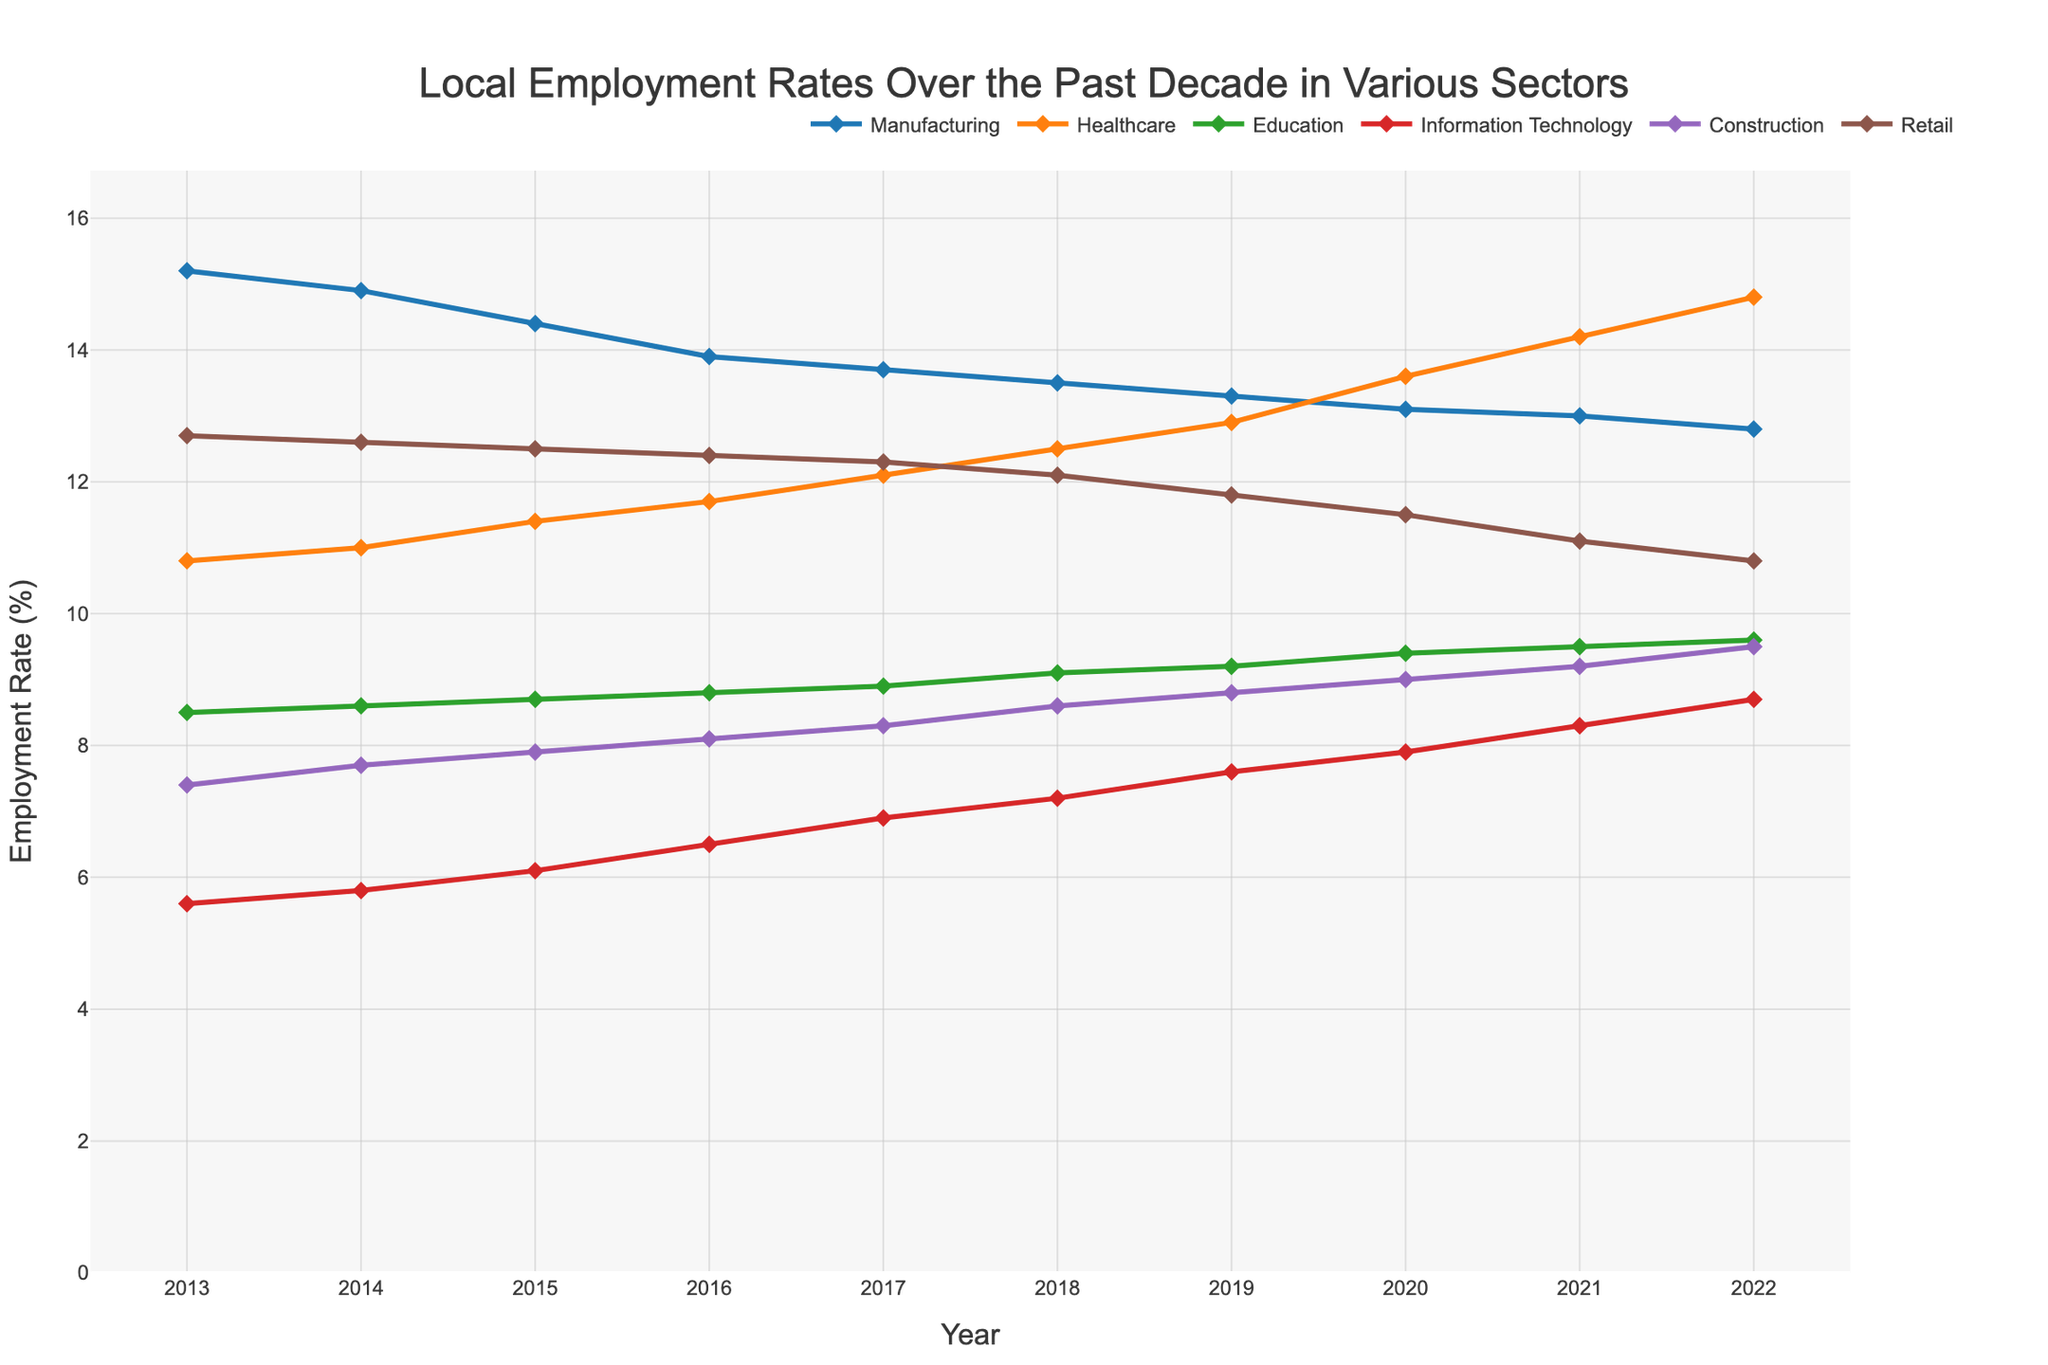What is the title of the figure? The title of a figure is typically located at the top of the visualization. In this case, above the plot, there is a clear title.
Answer: Local Employment Rates Over the Past Decade in Various Sectors How many sectors are represented in the plot? Each line represents a different sector. By counting the distinct lines or colors, one can identify the total number of sectors.
Answer: 6 Which sector had the highest employment rate in 2022? Follow the lines that correspond to each sector to the rightmost point on the x-axis labeled 2022 and compare the heights of these points.
Answer: Healthcare In which year did the Information Technology sector first reach an employment rate above 7%? Trace the line representing Information Technology and look for the first year where the y-value is greater than 7%.
Answer: 2018 What is the difference in employment rates between Healthcare and Manufacturing in 2020? Find the points for Healthcare and Manufacturing in 2020 on the x-axis and subtract the y-value of Manufacturing from the y-value of Healthcare.
Answer: 0.5% Which sector experienced the most growth in employment rate from 2013 to 2022? Calculate the difference between the employment rate in 2022 and 2013 for each sector and identify the sector with the largest positive difference.
Answer: Healthcare How did the employment rate in the Retail sector change from 2017 to 2022? Look at the Retail line and compare the y-values at 2017 and 2022. Determine if it increased or decreased and measure the difference.
Answer: Decreased by 1.5% Which two sectors had the closest employment rates in 2019? Compare the y-values for all sectors in 2019 and identify which two are closest to each other.
Answer: Information Technology and Construction Did any sector see a continuous increase in employment rate throughout the entire period from 2013 to 2022? Examine each sector's line from left to right to see if any line only increases every year without decrease.
Answer: No What was the average employment rate in the Education sector from 2013 to 2022? Sum the employment rates for the Education sector for all years and divide by the number of years (10).
Answer: 9.13% 